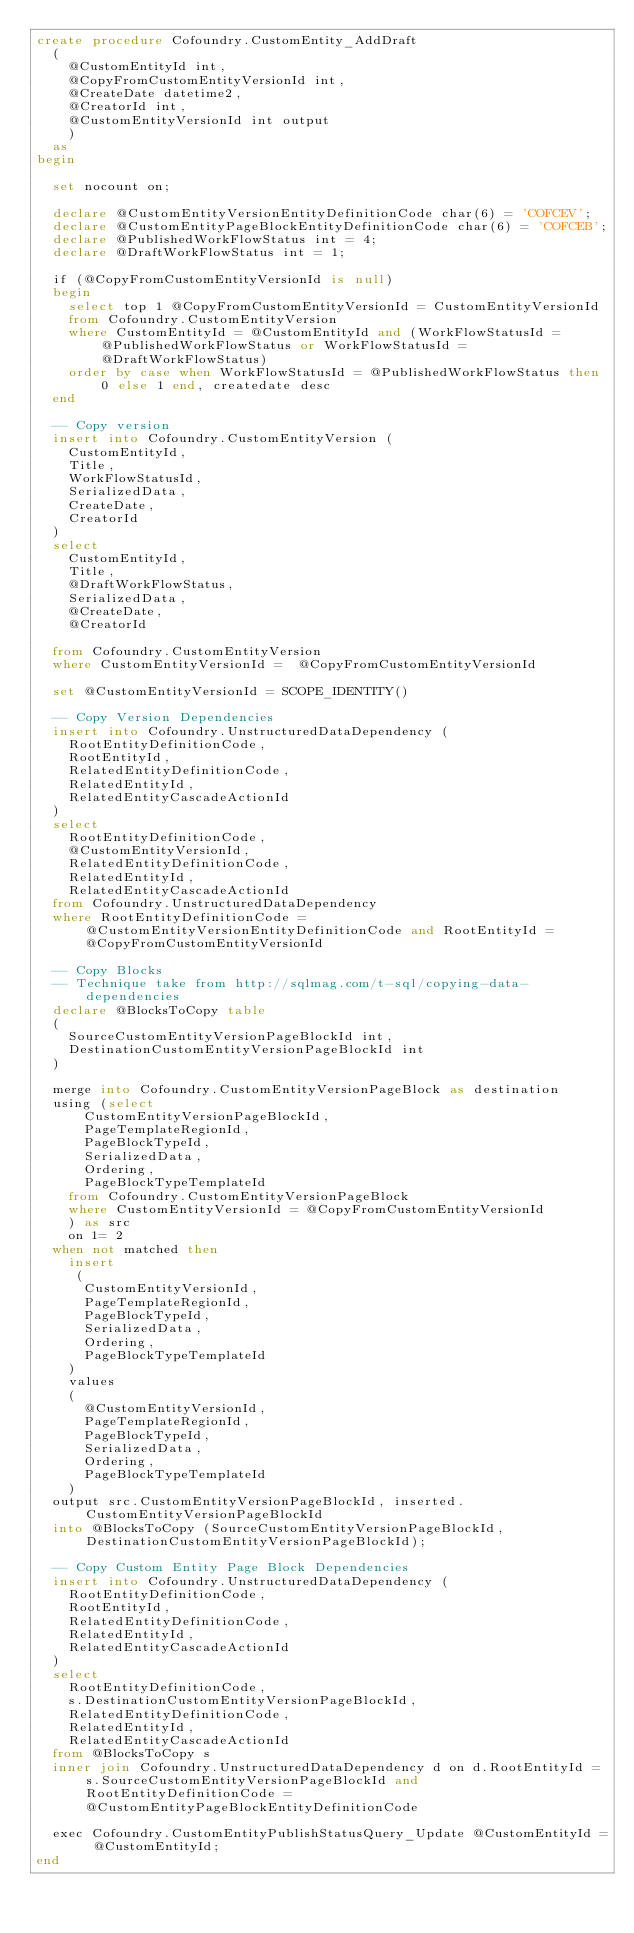<code> <loc_0><loc_0><loc_500><loc_500><_SQL_>create procedure Cofoundry.CustomEntity_AddDraft
	(
		@CustomEntityId int,
		@CopyFromCustomEntityVersionId int,
		@CreateDate datetime2,
		@CreatorId int,
		@CustomEntityVersionId int output
		)
	as
begin
	
	set nocount on;
	
	declare @CustomEntityVersionEntityDefinitionCode char(6) = 'COFCEV';
	declare @CustomEntityPageBlockEntityDefinitionCode char(6) = 'COFCEB';
	declare @PublishedWorkFlowStatus int = 4;
	declare @DraftWorkFlowStatus int = 1;

	if (@CopyFromCustomEntityVersionId is null)
	begin
		select top 1 @CopyFromCustomEntityVersionId = CustomEntityVersionId 
		from Cofoundry.CustomEntityVersion
		where CustomEntityId = @CustomEntityId and (WorkFlowStatusId = @PublishedWorkFlowStatus or WorkFlowStatusId = @DraftWorkFlowStatus)
		order by case when WorkFlowStatusId = @PublishedWorkFlowStatus then 0 else 1 end, createdate desc
	end

	-- Copy version
	insert into Cofoundry.CustomEntityVersion (
		CustomEntityId,
		Title,
		WorkFlowStatusId,
		SerializedData,
		CreateDate,
		CreatorId
	) 
	select
		CustomEntityId,
		Title,
		@DraftWorkFlowStatus,
		SerializedData,
		@CreateDate,
		@CreatorId
		
	from Cofoundry.CustomEntityVersion
	where CustomEntityVersionId =  @CopyFromCustomEntityVersionId

	set @CustomEntityVersionId = SCOPE_IDENTITY()
	
	-- Copy Version Dependencies
	insert into Cofoundry.UnstructuredDataDependency (
		RootEntityDefinitionCode,
		RootEntityId,
		RelatedEntityDefinitionCode,
		RelatedEntityId,
		RelatedEntityCascadeActionId
	)
	select 
		RootEntityDefinitionCode,
		@CustomEntityVersionId,
		RelatedEntityDefinitionCode,
		RelatedEntityId,
		RelatedEntityCascadeActionId
	from Cofoundry.UnstructuredDataDependency
	where RootEntityDefinitionCode = @CustomEntityVersionEntityDefinitionCode and RootEntityId = @CopyFromCustomEntityVersionId
	
	-- Copy Blocks
	-- Technique take from http://sqlmag.com/t-sql/copying-data-dependencies
	declare @BlocksToCopy table
	(
		SourceCustomEntityVersionPageBlockId int,
		DestinationCustomEntityVersionPageBlockId int
	)

	merge into Cofoundry.CustomEntityVersionPageBlock as destination
	using (select 
			CustomEntityVersionPageBlockId,
			PageTemplateRegionId,
			PageBlockTypeId,
			SerializedData,
			Ordering,
			PageBlockTypeTemplateId
		from Cofoundry.CustomEntityVersionPageBlock
		where CustomEntityVersionId = @CopyFromCustomEntityVersionId
		) as src
		on 1= 2
	when not matched then 
		insert 
		 (
			CustomEntityVersionId,
			PageTemplateRegionId,
			PageBlockTypeId,
			SerializedData,
			Ordering,
			PageBlockTypeTemplateId
		)
		values
		(
			@CustomEntityVersionId,
			PageTemplateRegionId,
			PageBlockTypeId,
			SerializedData,
			Ordering,
			PageBlockTypeTemplateId
		) 
	output src.CustomEntityVersionPageBlockId, inserted.CustomEntityVersionPageBlockId
	into @BlocksToCopy (SourceCustomEntityVersionPageBlockId, DestinationCustomEntityVersionPageBlockId);
	
	-- Copy Custom Entity Page Block Dependencies
	insert into Cofoundry.UnstructuredDataDependency (
		RootEntityDefinitionCode,
		RootEntityId,
		RelatedEntityDefinitionCode,
		RelatedEntityId,
		RelatedEntityCascadeActionId
	)
	select 
		RootEntityDefinitionCode,
		s.DestinationCustomEntityVersionPageBlockId,
		RelatedEntityDefinitionCode,
		RelatedEntityId,
		RelatedEntityCascadeActionId
	from @BlocksToCopy s
	inner join Cofoundry.UnstructuredDataDependency d on d.RootEntityId = s.SourceCustomEntityVersionPageBlockId and RootEntityDefinitionCode = @CustomEntityPageBlockEntityDefinitionCode
	
	exec Cofoundry.CustomEntityPublishStatusQuery_Update @CustomEntityId = @CustomEntityId;
end</code> 